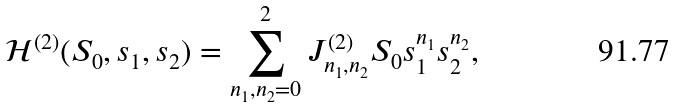<formula> <loc_0><loc_0><loc_500><loc_500>\mathcal { H } ^ { ( 2 ) } ( S _ { 0 } , s _ { 1 } , s _ { 2 } ) = \sum _ { n _ { 1 } , n _ { 2 } = 0 } ^ { 2 } J _ { n _ { 1 } , n _ { 2 } } ^ { ( 2 ) } S _ { 0 } s _ { 1 } ^ { n _ { 1 } } s _ { 2 } ^ { n _ { 2 } } ,</formula> 